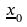Convert formula to latex. <formula><loc_0><loc_0><loc_500><loc_500>\underline { x } _ { 0 }</formula> 